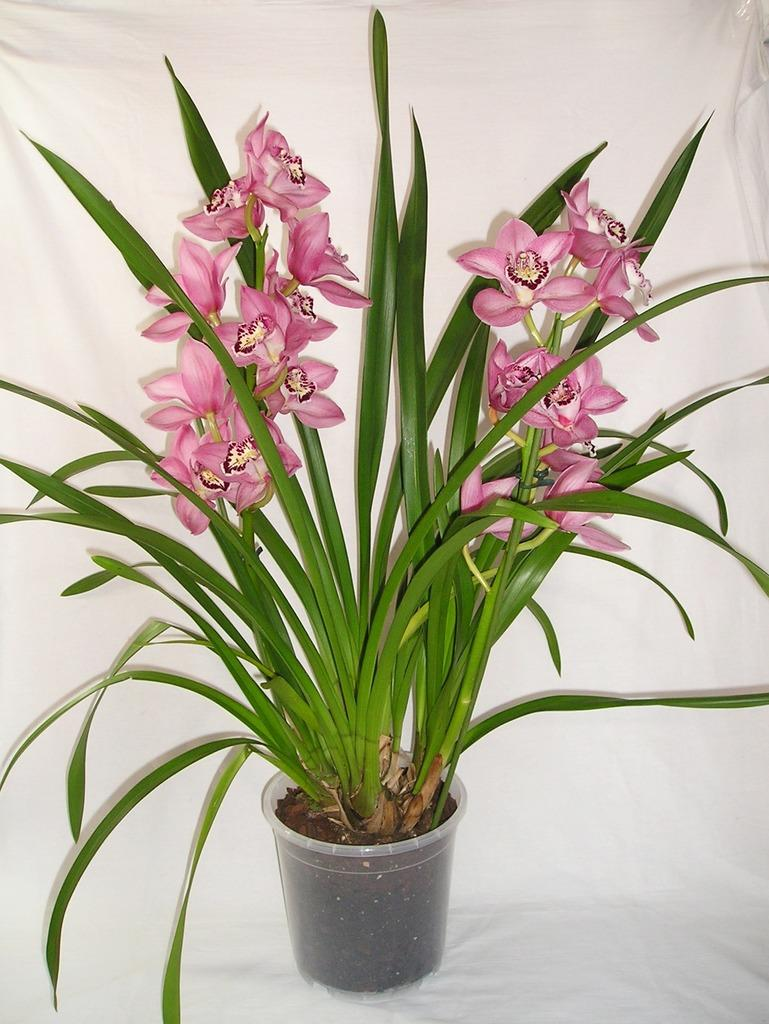What type of plant can be seen in the image? There is a houseplant in the image. How does the houseplant provide support for the man in the image? There is no man present in the image, and therefore no support is being provided by the houseplant. 